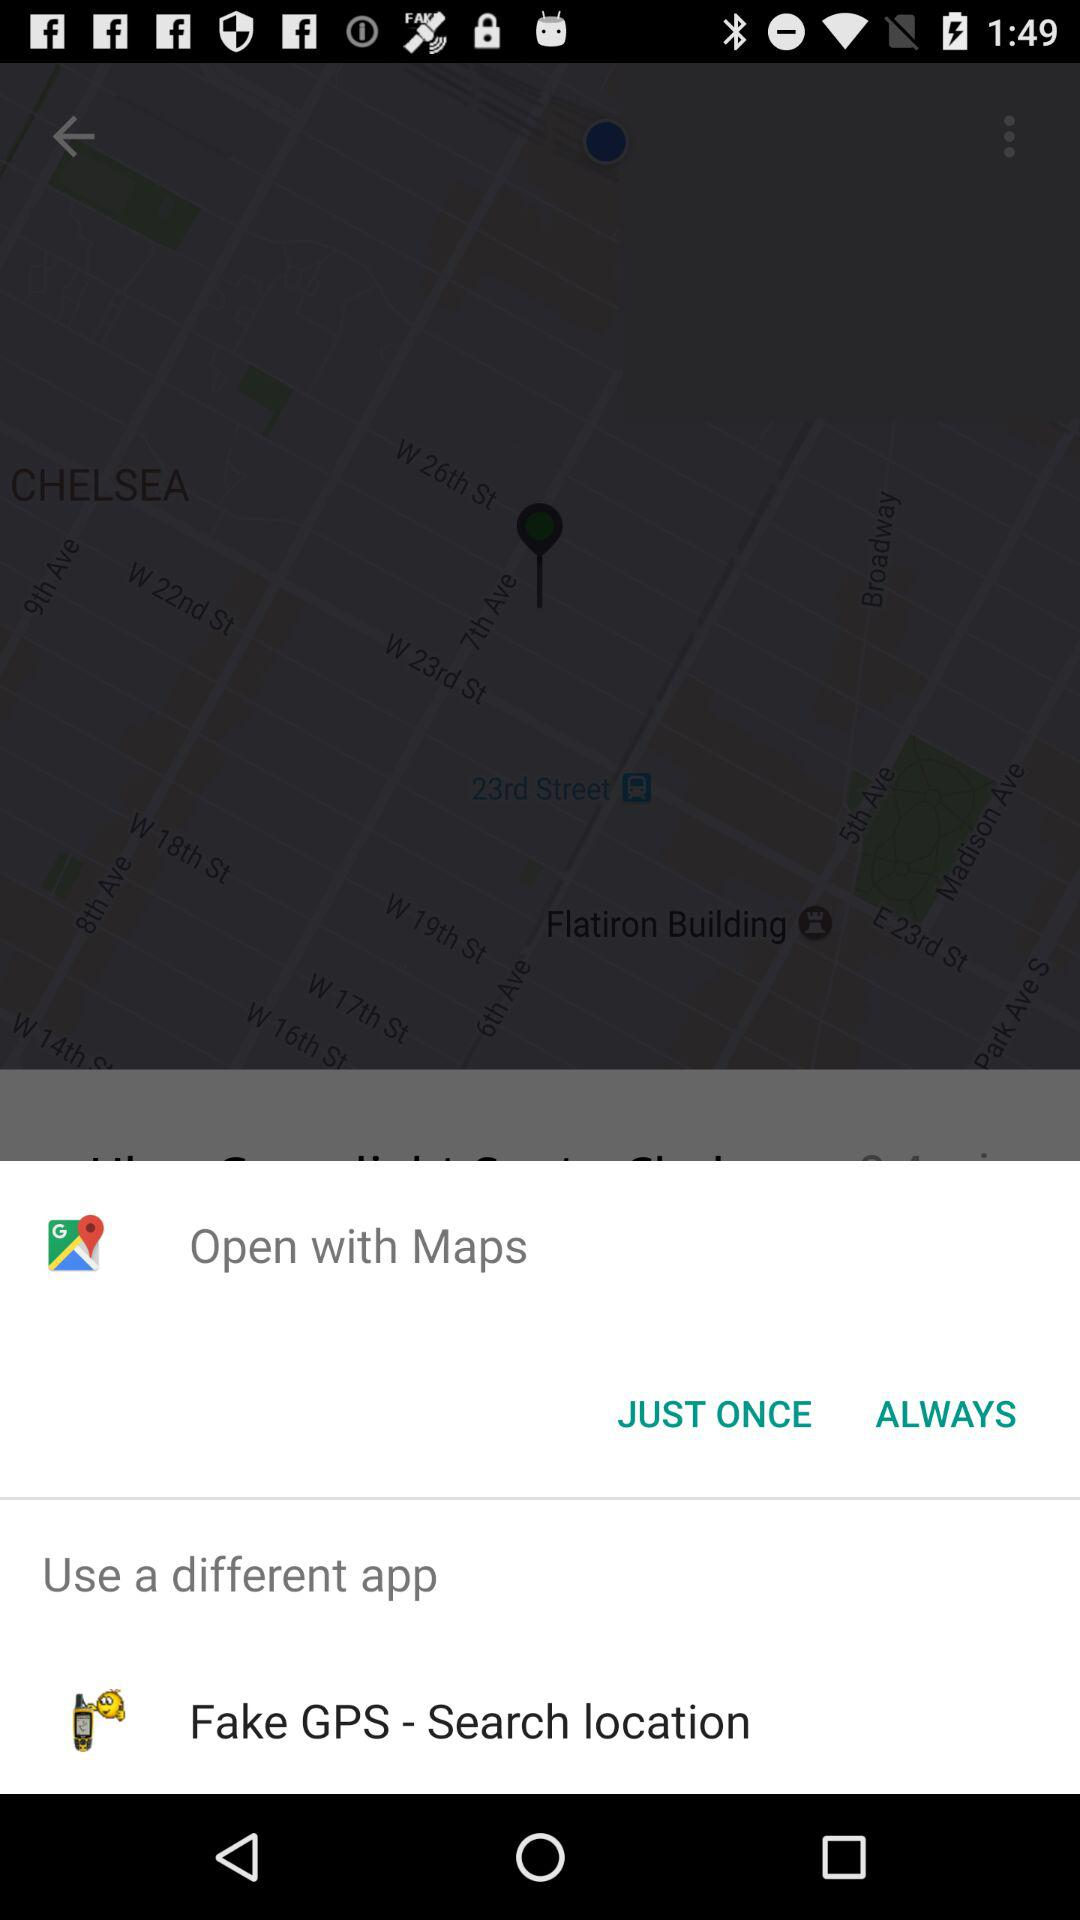Which application can we use to open it? You can use "Maps" and "Fake GPS - Search location" to open it. 